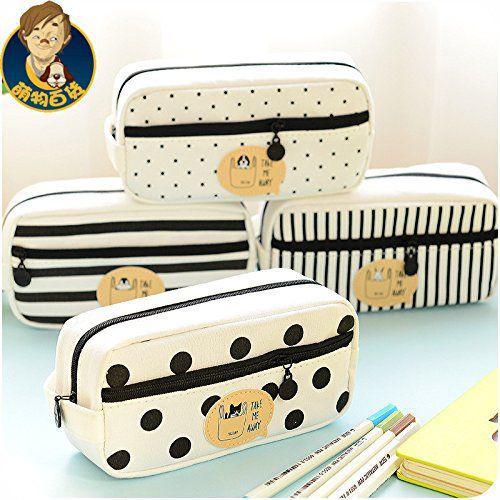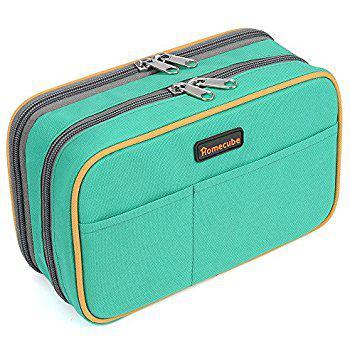The first image is the image on the left, the second image is the image on the right. Evaluate the accuracy of this statement regarding the images: "Four different variations of a pencil case, all of them closed, are depicted in one image.". Is it true? Answer yes or no. Yes. The first image is the image on the left, the second image is the image on the right. Evaluate the accuracy of this statement regarding the images: "Right and left images show the same number of pencil cases displayed in the same directional position.". Is it true? Answer yes or no. No. 